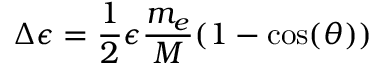<formula> <loc_0><loc_0><loc_500><loc_500>\Delta \epsilon = \frac { 1 } { 2 } \epsilon \frac { m _ { e } } { M } ( 1 - \cos ( \theta ) )</formula> 